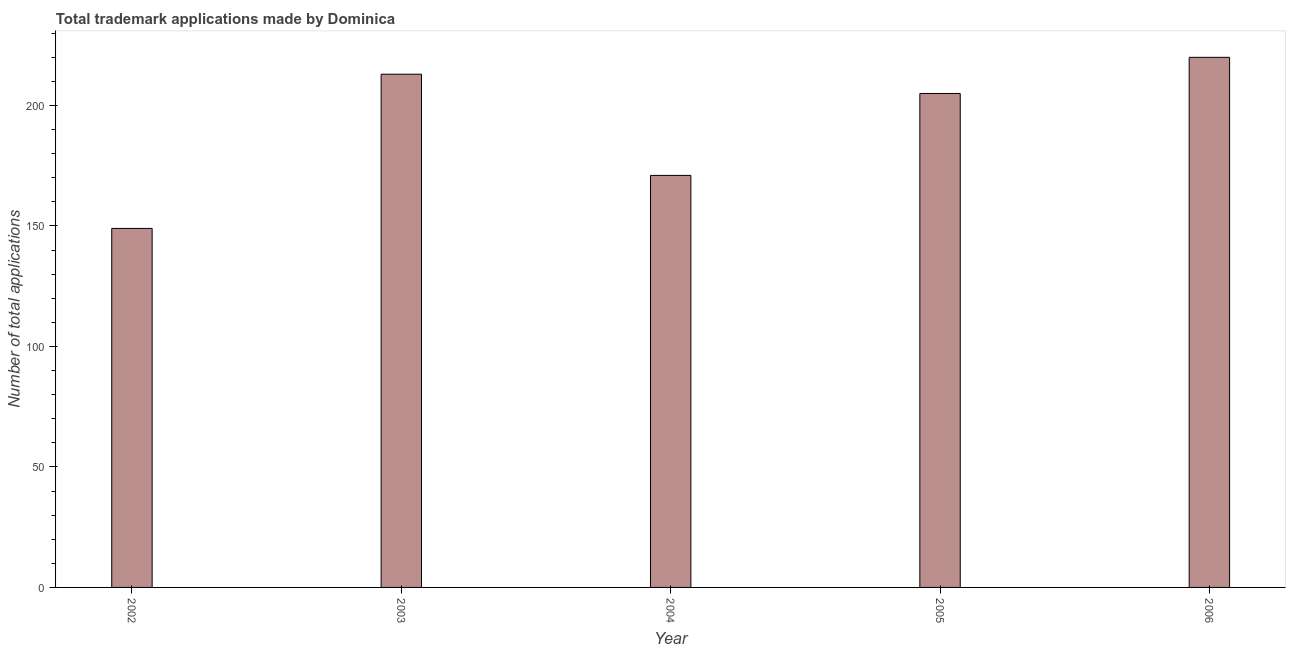Does the graph contain any zero values?
Provide a succinct answer. No. Does the graph contain grids?
Provide a short and direct response. No. What is the title of the graph?
Keep it short and to the point. Total trademark applications made by Dominica. What is the label or title of the X-axis?
Provide a short and direct response. Year. What is the label or title of the Y-axis?
Your response must be concise. Number of total applications. What is the number of trademark applications in 2006?
Provide a short and direct response. 220. Across all years, what is the maximum number of trademark applications?
Offer a very short reply. 220. Across all years, what is the minimum number of trademark applications?
Provide a succinct answer. 149. What is the sum of the number of trademark applications?
Make the answer very short. 958. What is the difference between the number of trademark applications in 2002 and 2005?
Make the answer very short. -56. What is the average number of trademark applications per year?
Provide a succinct answer. 191. What is the median number of trademark applications?
Your response must be concise. 205. What is the ratio of the number of trademark applications in 2002 to that in 2006?
Make the answer very short. 0.68. Is the number of trademark applications in 2004 less than that in 2005?
Make the answer very short. Yes. What is the difference between the highest and the second highest number of trademark applications?
Offer a very short reply. 7. Is the sum of the number of trademark applications in 2003 and 2006 greater than the maximum number of trademark applications across all years?
Give a very brief answer. Yes. In how many years, is the number of trademark applications greater than the average number of trademark applications taken over all years?
Ensure brevity in your answer.  3. How many bars are there?
Your response must be concise. 5. What is the difference between two consecutive major ticks on the Y-axis?
Ensure brevity in your answer.  50. What is the Number of total applications in 2002?
Provide a succinct answer. 149. What is the Number of total applications of 2003?
Keep it short and to the point. 213. What is the Number of total applications in 2004?
Provide a succinct answer. 171. What is the Number of total applications of 2005?
Your response must be concise. 205. What is the Number of total applications of 2006?
Your response must be concise. 220. What is the difference between the Number of total applications in 2002 and 2003?
Give a very brief answer. -64. What is the difference between the Number of total applications in 2002 and 2004?
Your response must be concise. -22. What is the difference between the Number of total applications in 2002 and 2005?
Provide a succinct answer. -56. What is the difference between the Number of total applications in 2002 and 2006?
Provide a succinct answer. -71. What is the difference between the Number of total applications in 2003 and 2004?
Ensure brevity in your answer.  42. What is the difference between the Number of total applications in 2004 and 2005?
Offer a terse response. -34. What is the difference between the Number of total applications in 2004 and 2006?
Make the answer very short. -49. What is the ratio of the Number of total applications in 2002 to that in 2003?
Your answer should be very brief. 0.7. What is the ratio of the Number of total applications in 2002 to that in 2004?
Provide a short and direct response. 0.87. What is the ratio of the Number of total applications in 2002 to that in 2005?
Your answer should be very brief. 0.73. What is the ratio of the Number of total applications in 2002 to that in 2006?
Offer a terse response. 0.68. What is the ratio of the Number of total applications in 2003 to that in 2004?
Offer a very short reply. 1.25. What is the ratio of the Number of total applications in 2003 to that in 2005?
Offer a terse response. 1.04. What is the ratio of the Number of total applications in 2004 to that in 2005?
Ensure brevity in your answer.  0.83. What is the ratio of the Number of total applications in 2004 to that in 2006?
Keep it short and to the point. 0.78. What is the ratio of the Number of total applications in 2005 to that in 2006?
Your answer should be compact. 0.93. 